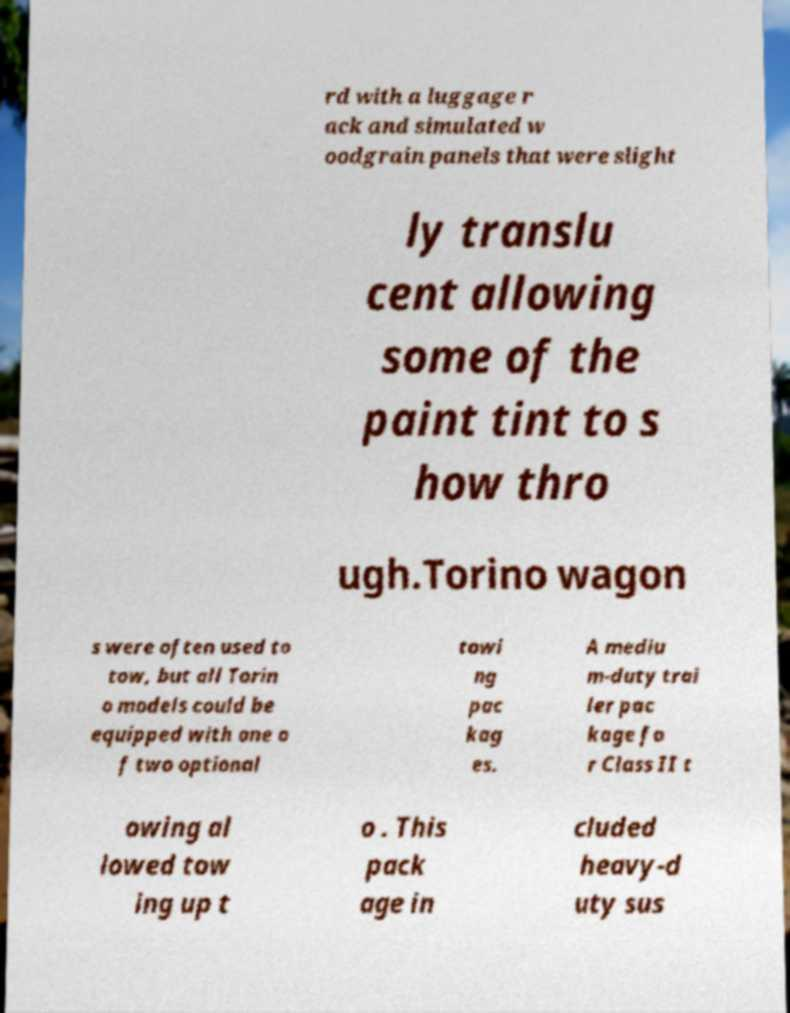There's text embedded in this image that I need extracted. Can you transcribe it verbatim? rd with a luggage r ack and simulated w oodgrain panels that were slight ly translu cent allowing some of the paint tint to s how thro ugh.Torino wagon s were often used to tow, but all Torin o models could be equipped with one o f two optional towi ng pac kag es. A mediu m-duty trai ler pac kage fo r Class II t owing al lowed tow ing up t o . This pack age in cluded heavy-d uty sus 